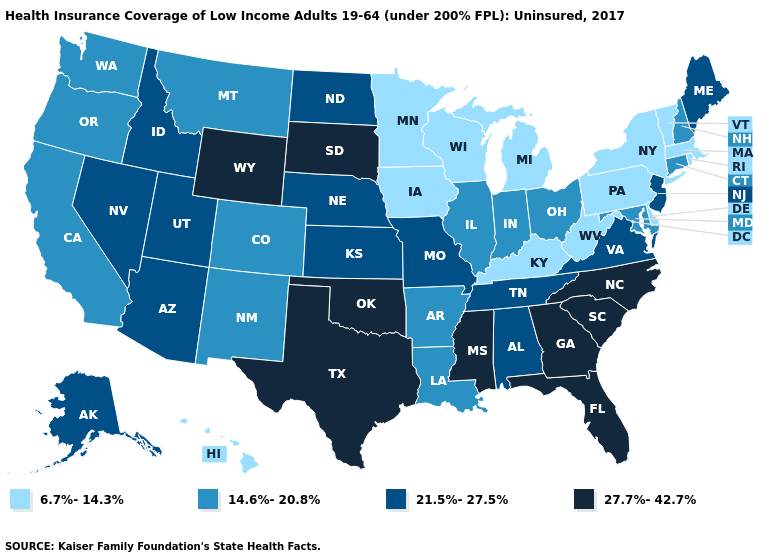Name the states that have a value in the range 6.7%-14.3%?
Quick response, please. Delaware, Hawaii, Iowa, Kentucky, Massachusetts, Michigan, Minnesota, New York, Pennsylvania, Rhode Island, Vermont, West Virginia, Wisconsin. What is the highest value in the USA?
Keep it brief. 27.7%-42.7%. Among the states that border Ohio , which have the highest value?
Write a very short answer. Indiana. Name the states that have a value in the range 21.5%-27.5%?
Answer briefly. Alabama, Alaska, Arizona, Idaho, Kansas, Maine, Missouri, Nebraska, Nevada, New Jersey, North Dakota, Tennessee, Utah, Virginia. Does the map have missing data?
Give a very brief answer. No. What is the value of New Hampshire?
Quick response, please. 14.6%-20.8%. Among the states that border Tennessee , which have the highest value?
Short answer required. Georgia, Mississippi, North Carolina. Name the states that have a value in the range 6.7%-14.3%?
Give a very brief answer. Delaware, Hawaii, Iowa, Kentucky, Massachusetts, Michigan, Minnesota, New York, Pennsylvania, Rhode Island, Vermont, West Virginia, Wisconsin. Name the states that have a value in the range 6.7%-14.3%?
Keep it brief. Delaware, Hawaii, Iowa, Kentucky, Massachusetts, Michigan, Minnesota, New York, Pennsylvania, Rhode Island, Vermont, West Virginia, Wisconsin. Name the states that have a value in the range 21.5%-27.5%?
Keep it brief. Alabama, Alaska, Arizona, Idaho, Kansas, Maine, Missouri, Nebraska, Nevada, New Jersey, North Dakota, Tennessee, Utah, Virginia. Name the states that have a value in the range 21.5%-27.5%?
Be succinct. Alabama, Alaska, Arizona, Idaho, Kansas, Maine, Missouri, Nebraska, Nevada, New Jersey, North Dakota, Tennessee, Utah, Virginia. Name the states that have a value in the range 14.6%-20.8%?
Write a very short answer. Arkansas, California, Colorado, Connecticut, Illinois, Indiana, Louisiana, Maryland, Montana, New Hampshire, New Mexico, Ohio, Oregon, Washington. Name the states that have a value in the range 21.5%-27.5%?
Write a very short answer. Alabama, Alaska, Arizona, Idaho, Kansas, Maine, Missouri, Nebraska, Nevada, New Jersey, North Dakota, Tennessee, Utah, Virginia. Does Hawaii have the lowest value in the West?
Give a very brief answer. Yes. 